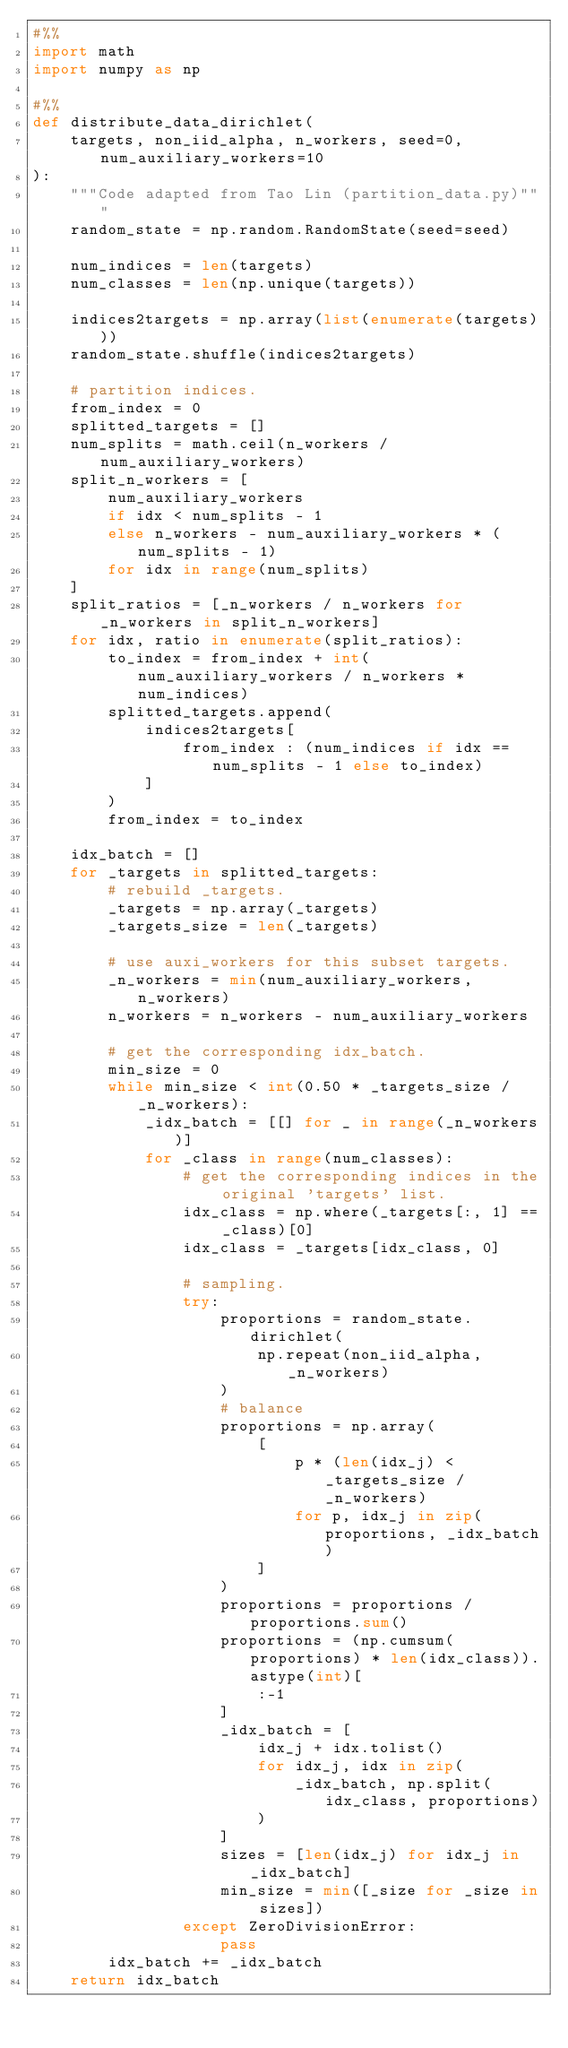<code> <loc_0><loc_0><loc_500><loc_500><_Python_>#%%
import math
import numpy as np

#%%
def distribute_data_dirichlet(
    targets, non_iid_alpha, n_workers, seed=0, num_auxiliary_workers=10
):
    """Code adapted from Tao Lin (partition_data.py)"""
    random_state = np.random.RandomState(seed=seed)

    num_indices = len(targets)
    num_classes = len(np.unique(targets))

    indices2targets = np.array(list(enumerate(targets)))
    random_state.shuffle(indices2targets)

    # partition indices.
    from_index = 0
    splitted_targets = []
    num_splits = math.ceil(n_workers / num_auxiliary_workers)
    split_n_workers = [
        num_auxiliary_workers
        if idx < num_splits - 1
        else n_workers - num_auxiliary_workers * (num_splits - 1)
        for idx in range(num_splits)
    ]
    split_ratios = [_n_workers / n_workers for _n_workers in split_n_workers]
    for idx, ratio in enumerate(split_ratios):
        to_index = from_index + int(num_auxiliary_workers / n_workers * num_indices)
        splitted_targets.append(
            indices2targets[
                from_index : (num_indices if idx == num_splits - 1 else to_index)
            ]
        )
        from_index = to_index

    idx_batch = []
    for _targets in splitted_targets:
        # rebuild _targets.
        _targets = np.array(_targets)
        _targets_size = len(_targets)

        # use auxi_workers for this subset targets.
        _n_workers = min(num_auxiliary_workers, n_workers)
        n_workers = n_workers - num_auxiliary_workers

        # get the corresponding idx_batch.
        min_size = 0
        while min_size < int(0.50 * _targets_size / _n_workers):
            _idx_batch = [[] for _ in range(_n_workers)]
            for _class in range(num_classes):
                # get the corresponding indices in the original 'targets' list.
                idx_class = np.where(_targets[:, 1] == _class)[0]
                idx_class = _targets[idx_class, 0]

                # sampling.
                try:
                    proportions = random_state.dirichlet(
                        np.repeat(non_iid_alpha, _n_workers)
                    )
                    # balance
                    proportions = np.array(
                        [
                            p * (len(idx_j) < _targets_size / _n_workers)
                            for p, idx_j in zip(proportions, _idx_batch)
                        ]
                    )
                    proportions = proportions / proportions.sum()
                    proportions = (np.cumsum(proportions) * len(idx_class)).astype(int)[
                        :-1
                    ]
                    _idx_batch = [
                        idx_j + idx.tolist()
                        for idx_j, idx in zip(
                            _idx_batch, np.split(idx_class, proportions)
                        )
                    ]
                    sizes = [len(idx_j) for idx_j in _idx_batch]
                    min_size = min([_size for _size in sizes])
                except ZeroDivisionError:
                    pass
        idx_batch += _idx_batch
    return idx_batch
</code> 